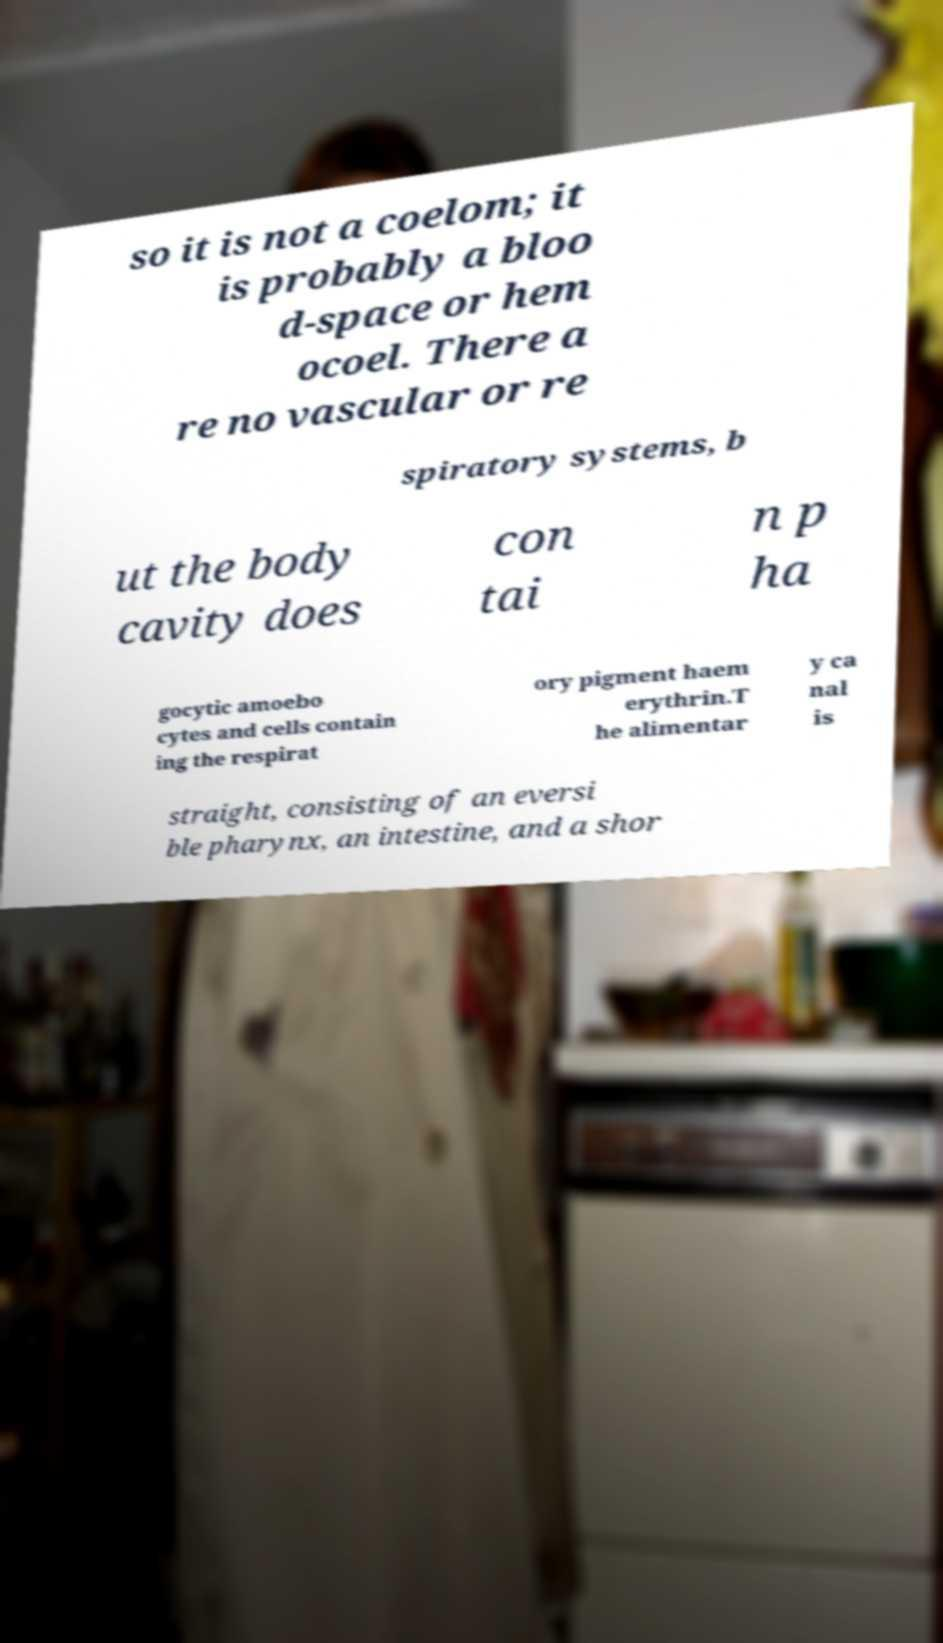What messages or text are displayed in this image? I need them in a readable, typed format. so it is not a coelom; it is probably a bloo d-space or hem ocoel. There a re no vascular or re spiratory systems, b ut the body cavity does con tai n p ha gocytic amoebo cytes and cells contain ing the respirat ory pigment haem erythrin.T he alimentar y ca nal is straight, consisting of an eversi ble pharynx, an intestine, and a shor 